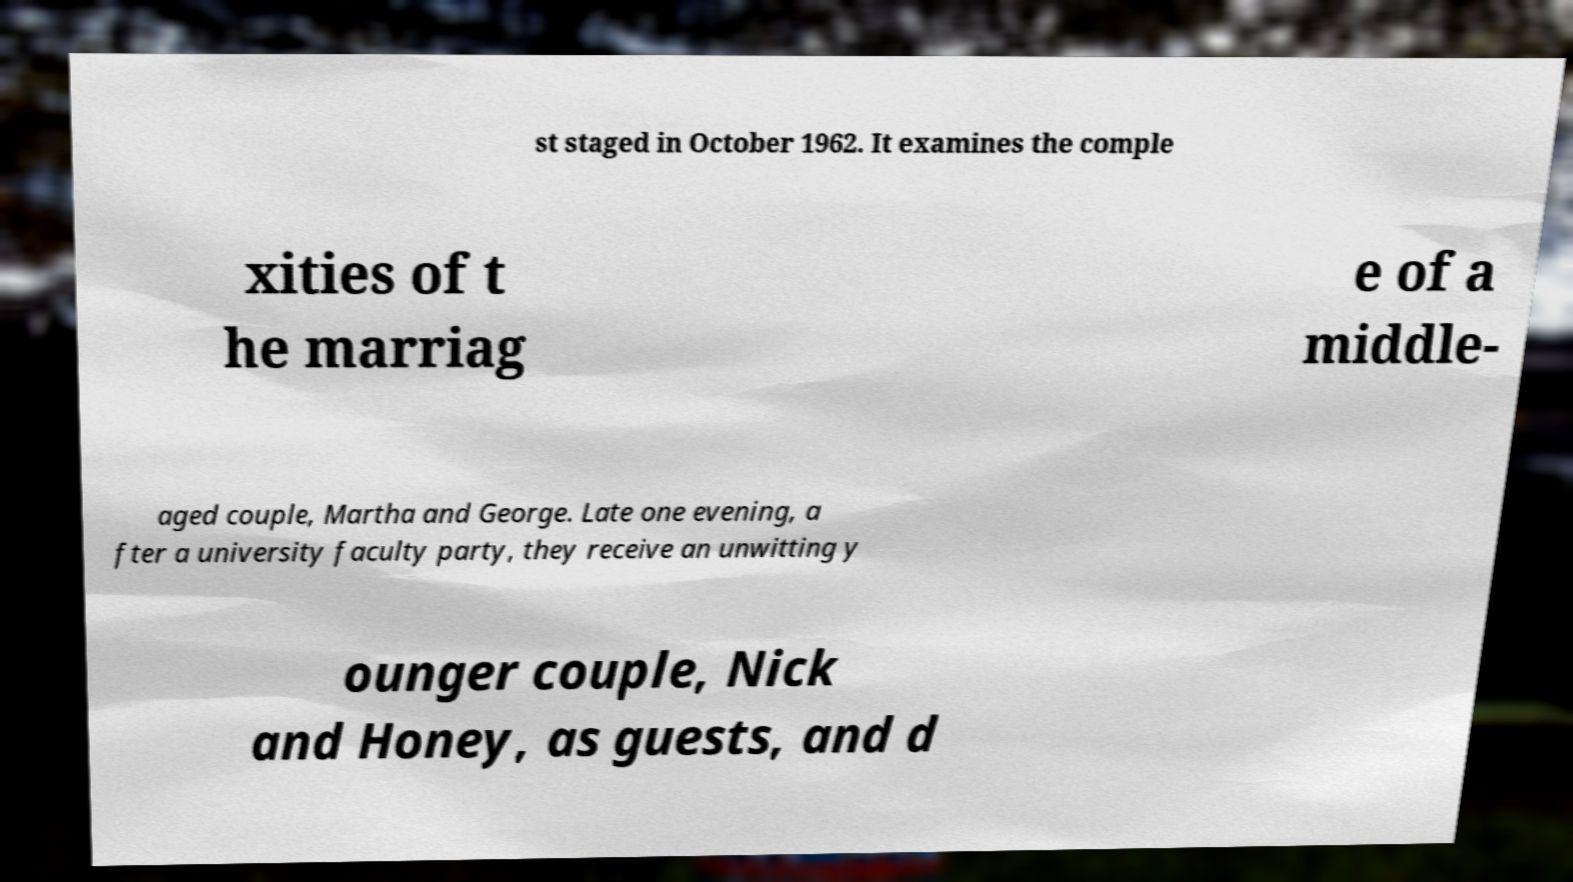What messages or text are displayed in this image? I need them in a readable, typed format. st staged in October 1962. It examines the comple xities of t he marriag e of a middle- aged couple, Martha and George. Late one evening, a fter a university faculty party, they receive an unwitting y ounger couple, Nick and Honey, as guests, and d 